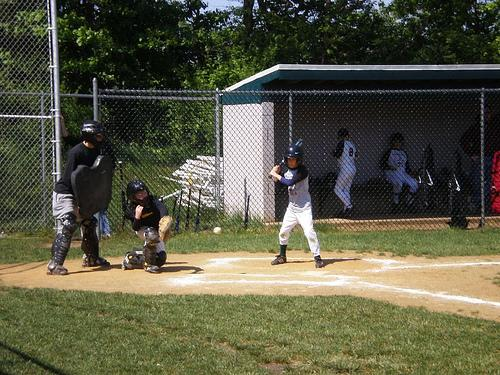Where do those who await their turn at bat wait?

Choices:
A) mall
B) home base
C) behind fence
D) outfield behind fence 